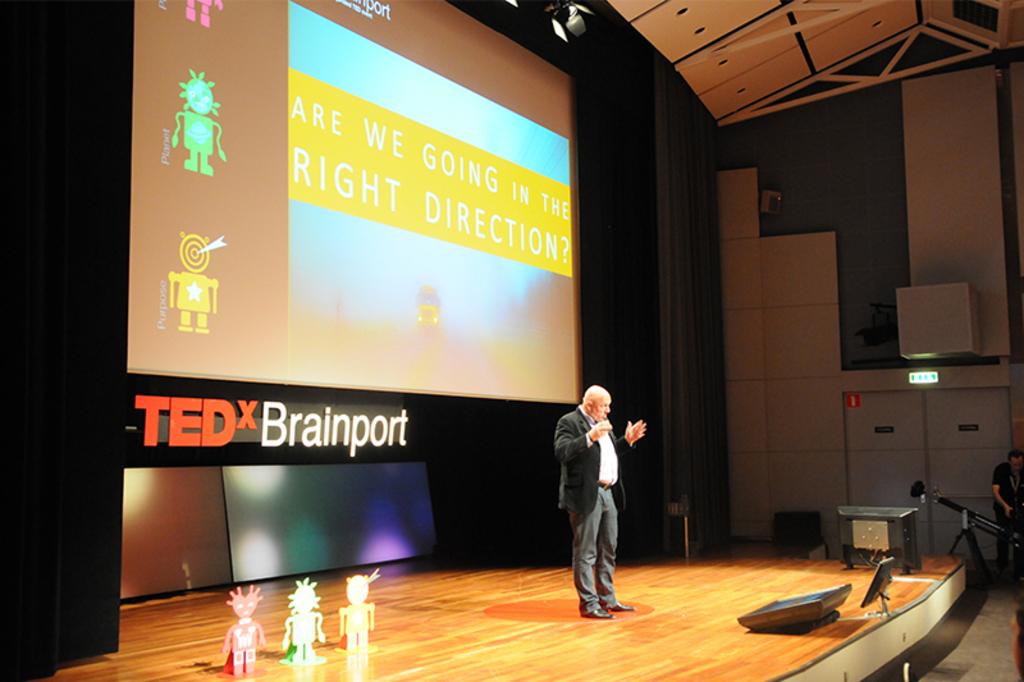What is the slide saying in the yellow area?
Your response must be concise. Are we going in the right direction?. 